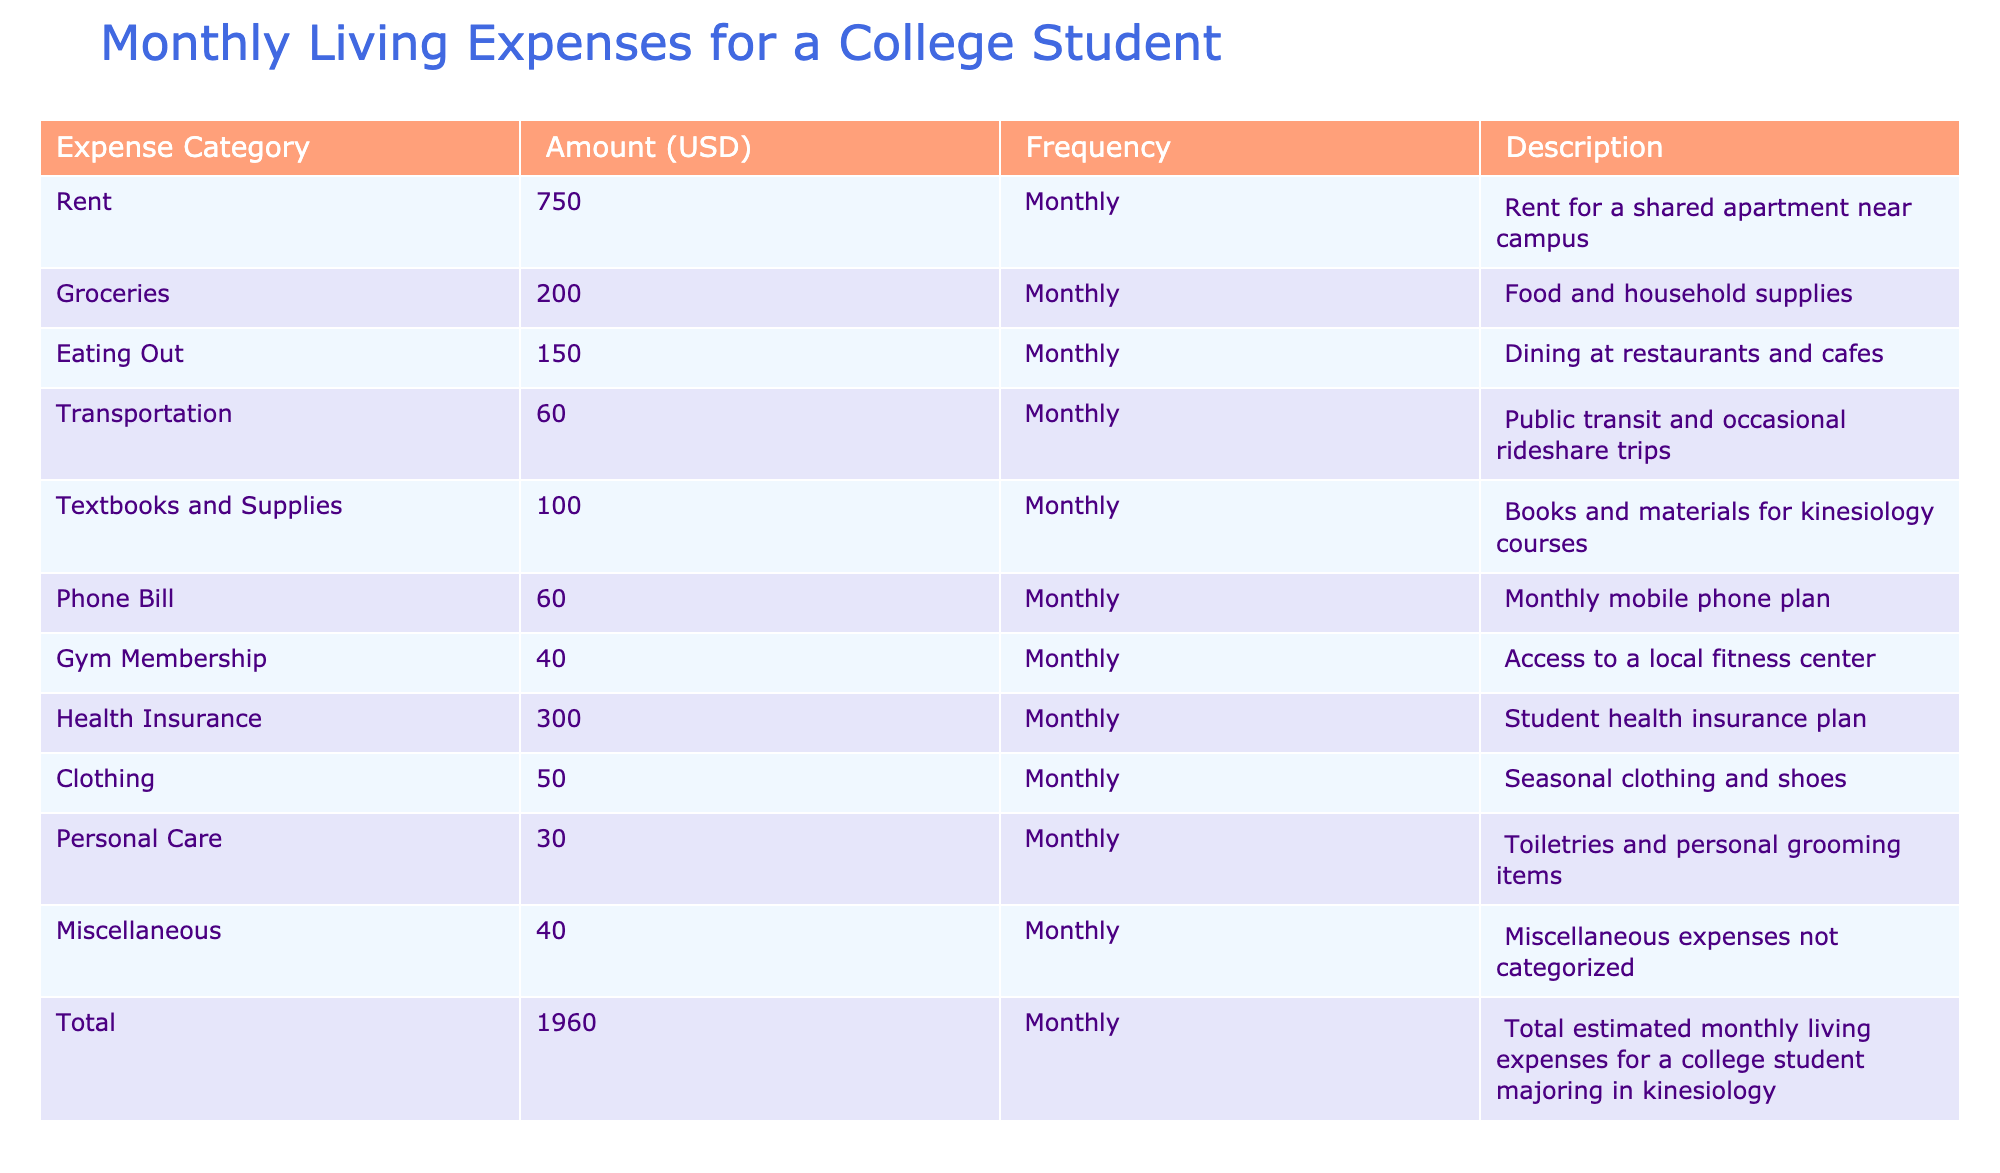What is the highest monthly living expense? The table lists several expense categories. Looking for the highest value from the Amount column, Health Insurance has the highest amount of 300 USD.
Answer: 300 What is the total amount spent on groceries and eating out? To find the combined amount for groceries and eating out, I add the two corresponding values: 200 (Groceries) + 150 (Eating Out) = 350.
Answer: 350 Is the amount spent on a gym membership less than the amount spent on clothing? The table shows 40 USD for Gym Membership and 50 USD for Clothing. Since 40 is less than 50, the statement is true.
Answer: Yes What are the three lowest monthly living expenses? Reviewing the Amount column, the three lowest expenses are Personal Care (30), Gym Membership (40), and Miscellaneous (40).
Answer: Personal Care, Gym Membership, Miscellaneous What is the total percentage of the budget spent on transportation and miscellaneous expenses? First, I add the amounts for Transportation (60) and Miscellaneous (40), giving a total of 100. Then, to find the percentage of this combined amount against the Total (1960), the calculation is (100 / 1960) * 100 = 5.10%.
Answer: 5.10% Are the amounts for Textbooks and Supplies and Transportation equal? The table displays 100 USD for Textbooks and 60 USD for Transportation. Since 100 is not equal to 60, this statement is false.
Answer: No What is the total amount spent each month on utilities (including phone bill and health insurance, if they are deemed utilities)? According to the table, the Phone Bill is 60 and Health Insurance is 300. Adding these gives 60 + 300 = 360 as the total amount.
Answer: 360 What is the average amount spent on personal care, clothing, and eating out? I first find the total of those expenses: Personal Care (30) + Clothing (50) + Eating Out (150) = 230. Since there are 3 categories, I divide the total by 3, giving 230 / 3 = 76.67.
Answer: 76.67 